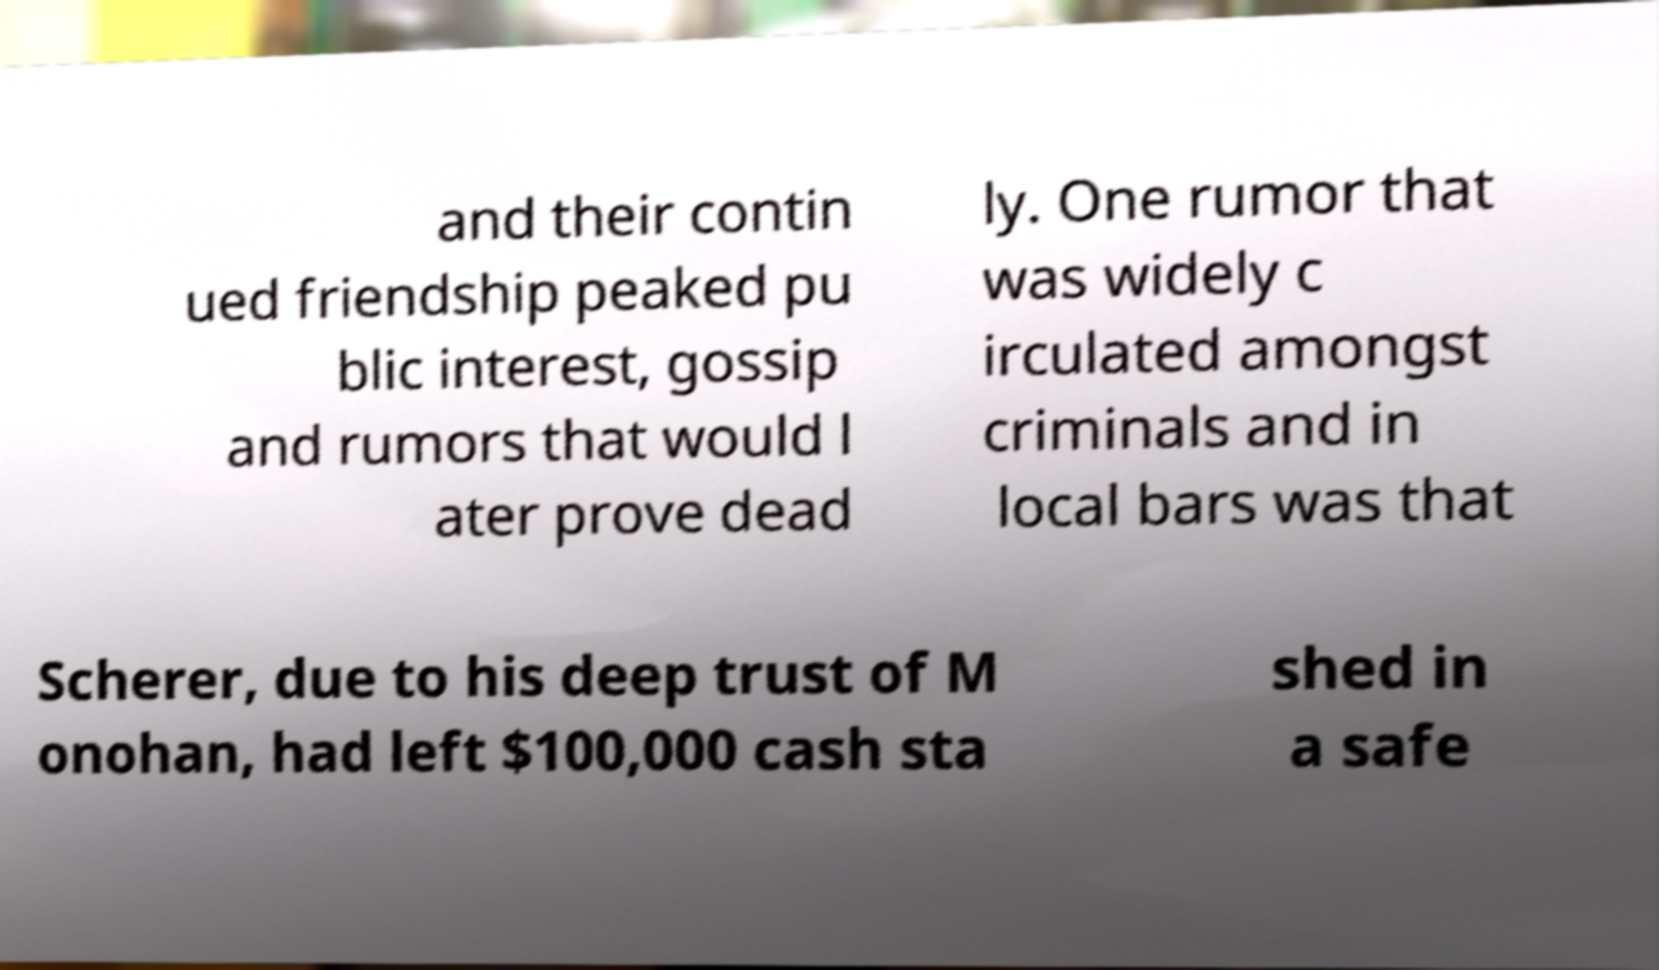I need the written content from this picture converted into text. Can you do that? and their contin ued friendship peaked pu blic interest, gossip and rumors that would l ater prove dead ly. One rumor that was widely c irculated amongst criminals and in local bars was that Scherer, due to his deep trust of M onohan, had left $100,000 cash sta shed in a safe 